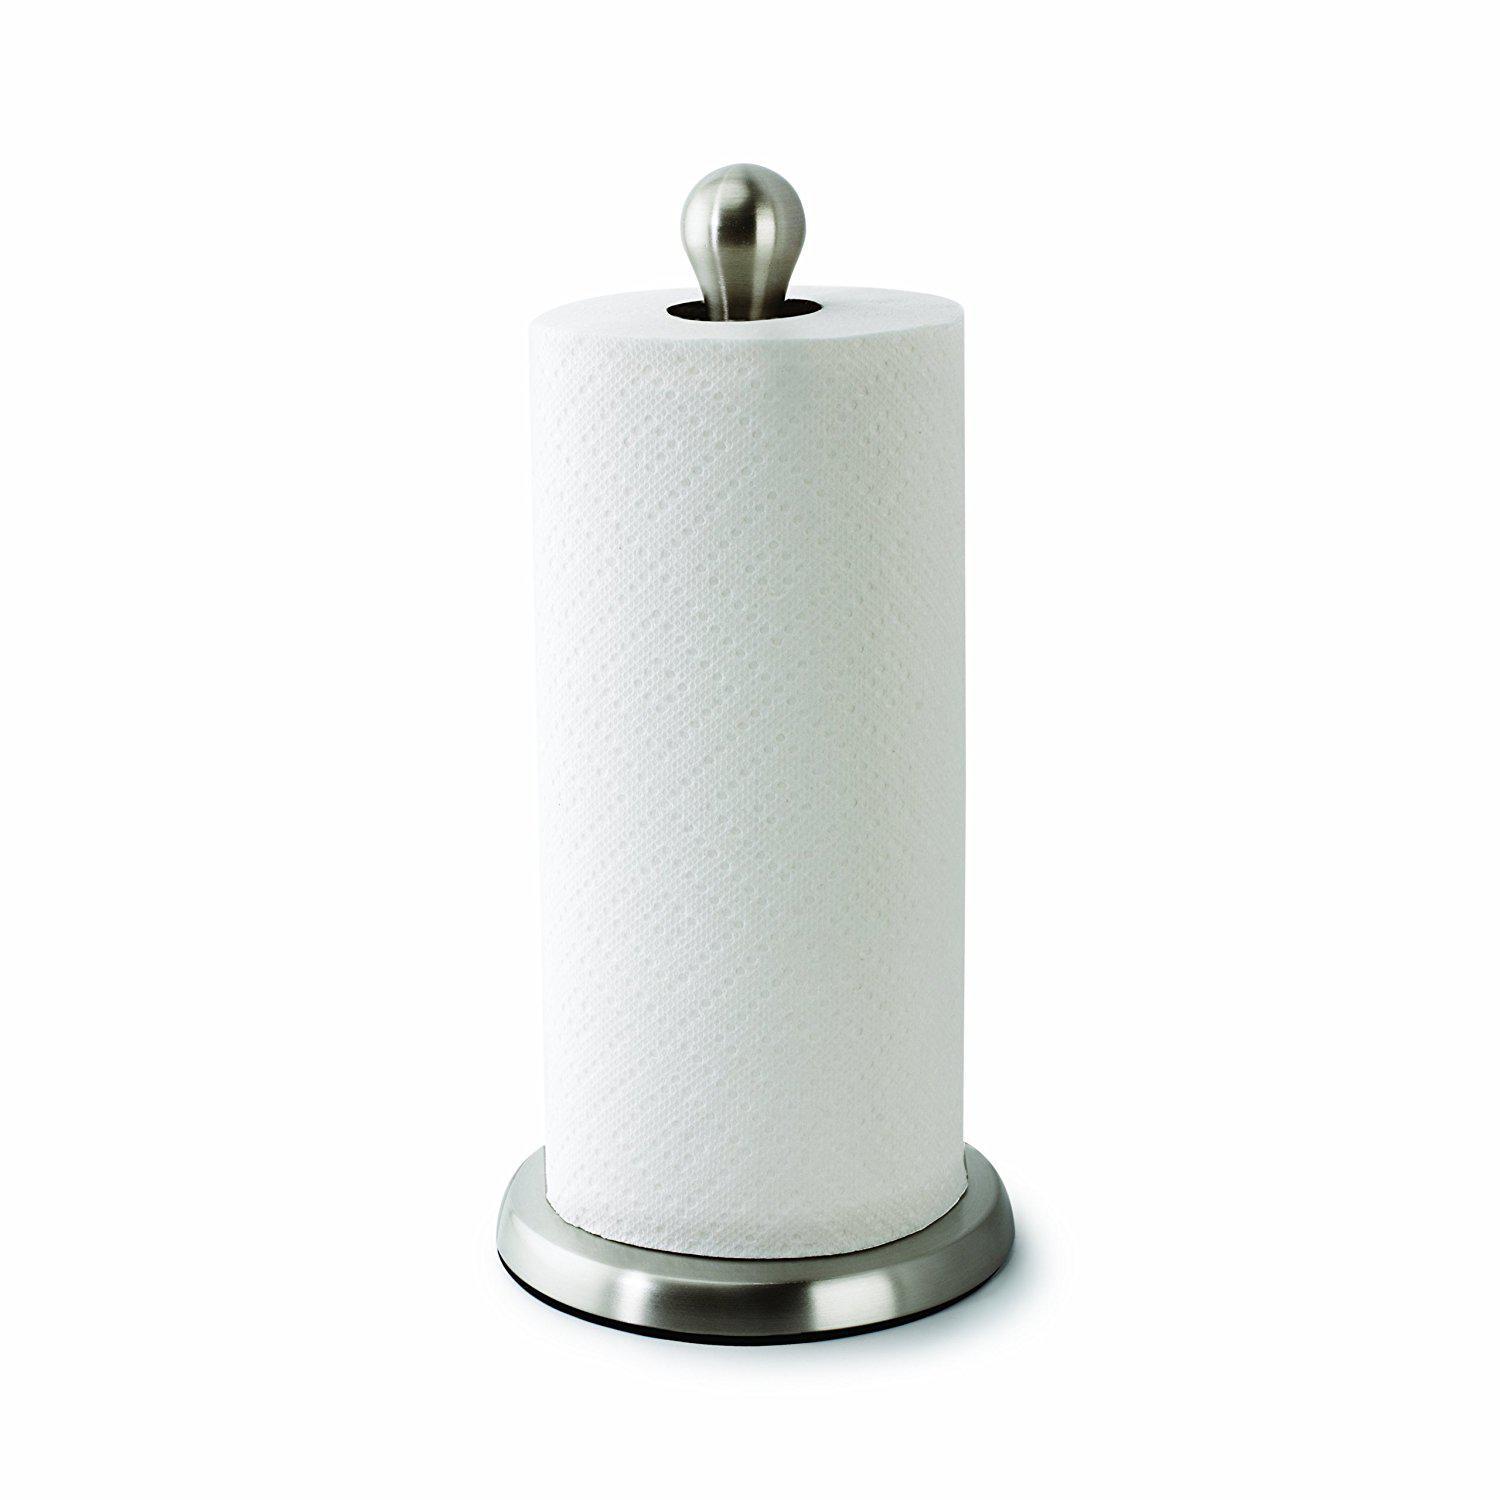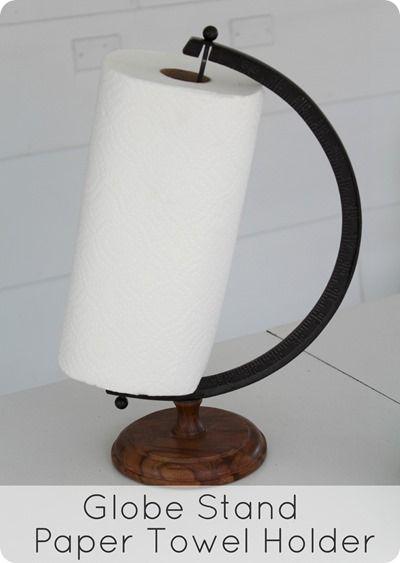The first image is the image on the left, the second image is the image on the right. Considering the images on both sides, is "There are more than two rolls in each image." valid? Answer yes or no. No. 